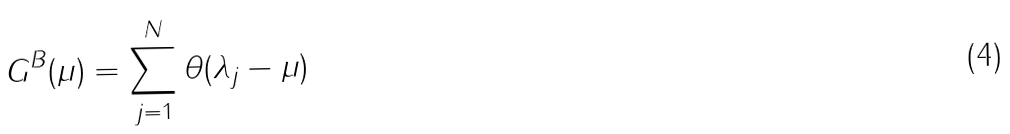Convert formula to latex. <formula><loc_0><loc_0><loc_500><loc_500>G ^ { B } ( \mu ) = \sum _ { j = 1 } ^ { N } \theta ( \lambda _ { j } - \mu )</formula> 